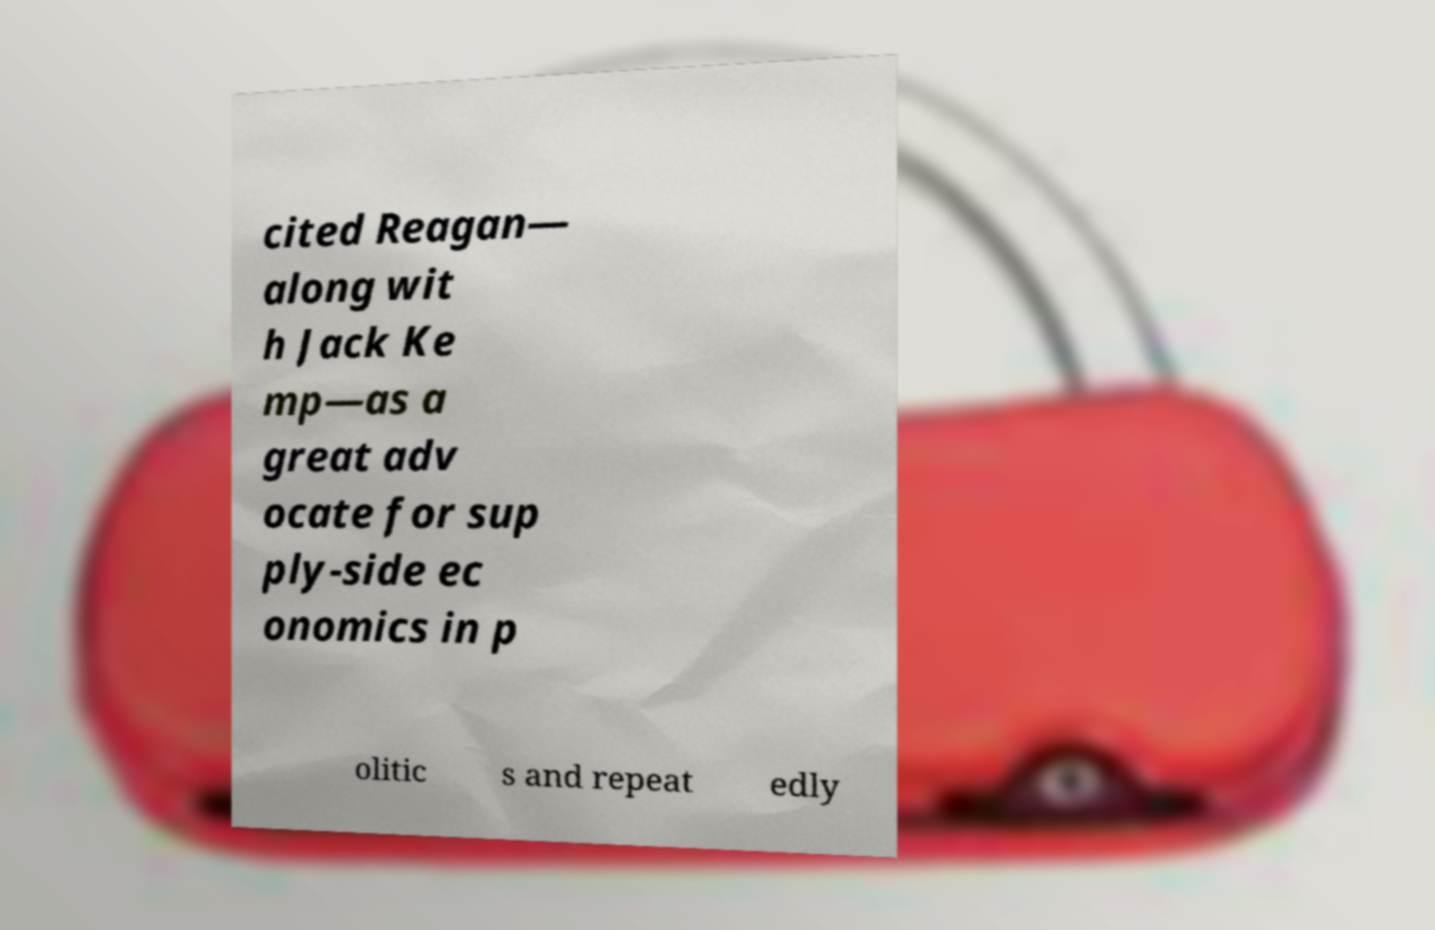Could you extract and type out the text from this image? cited Reagan— along wit h Jack Ke mp—as a great adv ocate for sup ply-side ec onomics in p olitic s and repeat edly 